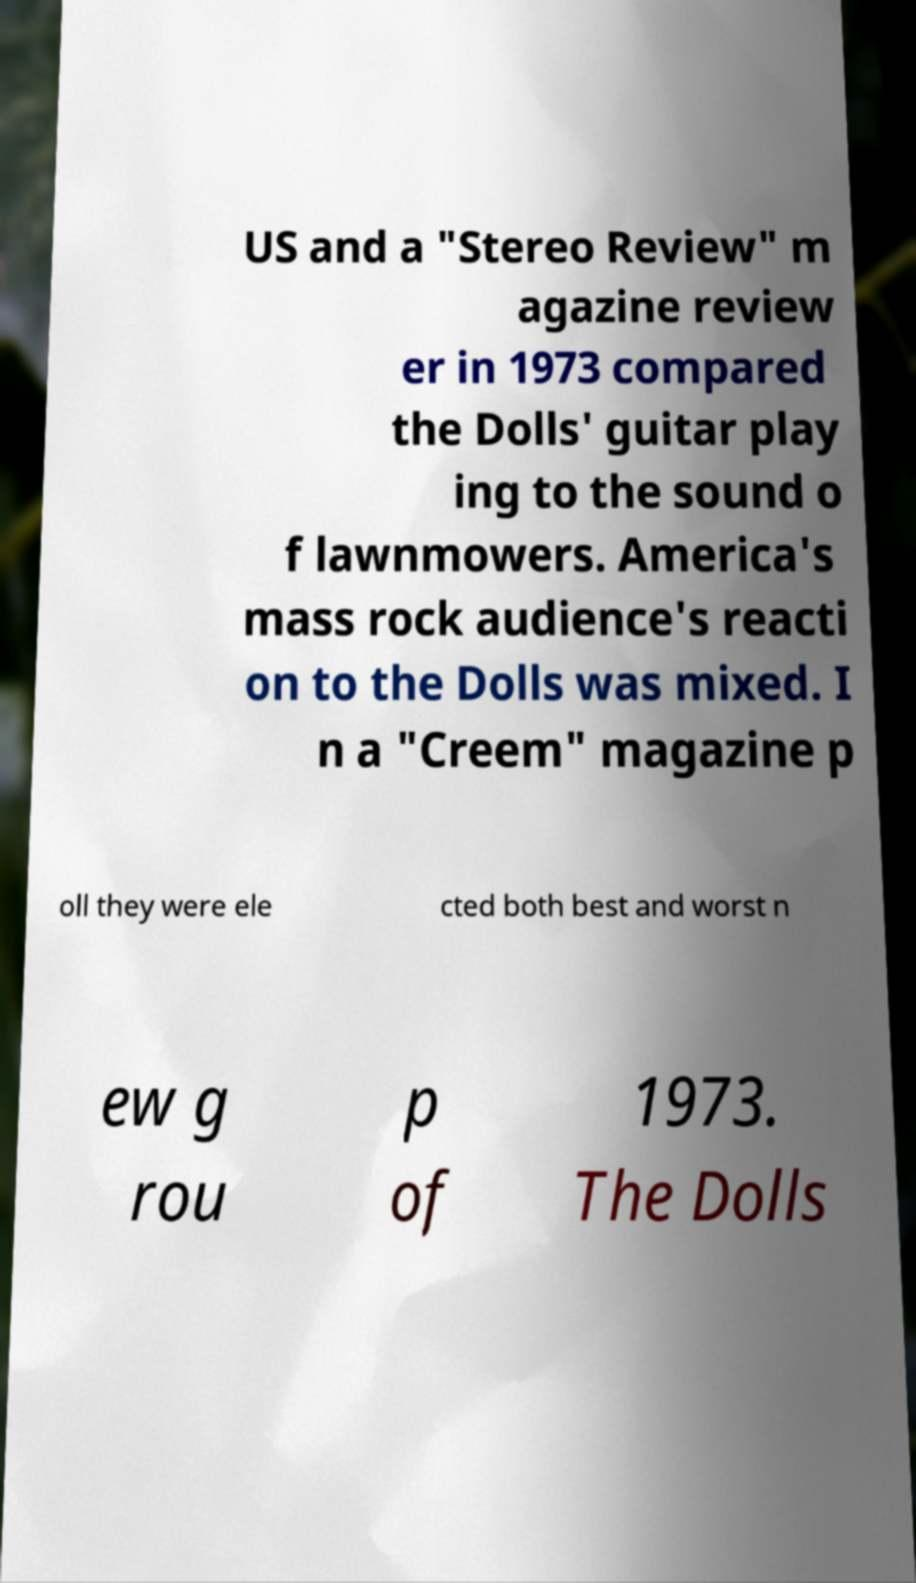I need the written content from this picture converted into text. Can you do that? US and a "Stereo Review" m agazine review er in 1973 compared the Dolls' guitar play ing to the sound o f lawnmowers. America's mass rock audience's reacti on to the Dolls was mixed. I n a "Creem" magazine p oll they were ele cted both best and worst n ew g rou p of 1973. The Dolls 